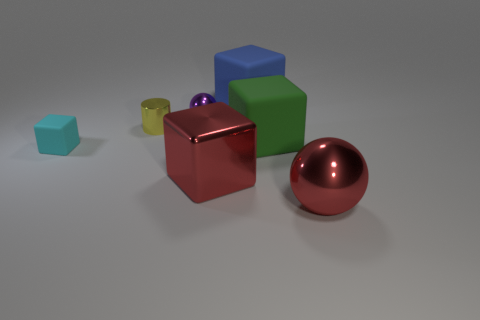What size is the metallic thing that is the same color as the large ball?
Ensure brevity in your answer.  Large. Do the tiny purple metal object and the metal object that is to the right of the blue object have the same shape?
Your answer should be very brief. Yes. Is the shape of the big blue matte thing the same as the green object?
Offer a very short reply. Yes. There is a ball that is behind the large ball; what size is it?
Your answer should be compact. Small. Are there any objects of the same color as the big ball?
Ensure brevity in your answer.  Yes. How many red shiny objects are the same shape as the blue thing?
Offer a very short reply. 1. There is a big green object; what shape is it?
Keep it short and to the point. Cube. Are there fewer large red metallic objects than cubes?
Your answer should be compact. Yes. What material is the large red object that is the same shape as the green matte thing?
Your answer should be compact. Metal. Is the number of tiny metal cylinders greater than the number of tiny things?
Ensure brevity in your answer.  No. 